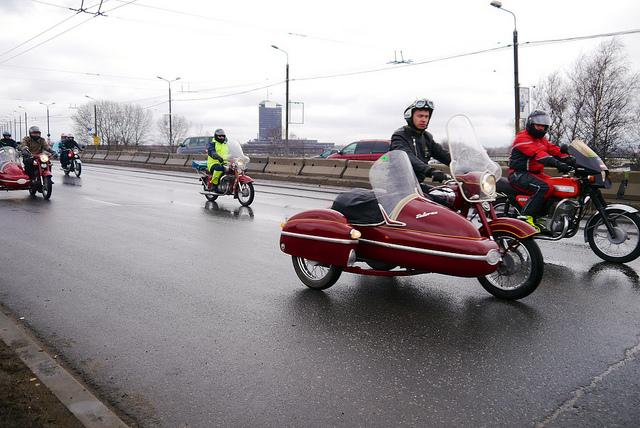What could have made the road appear shiny?

Choices:
A) wind
B) rain
C) snow
D) paint rain 